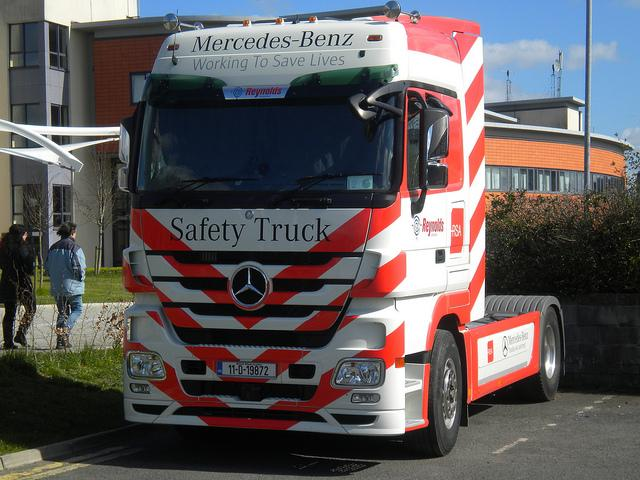Why does it say safety truck? saves lives 